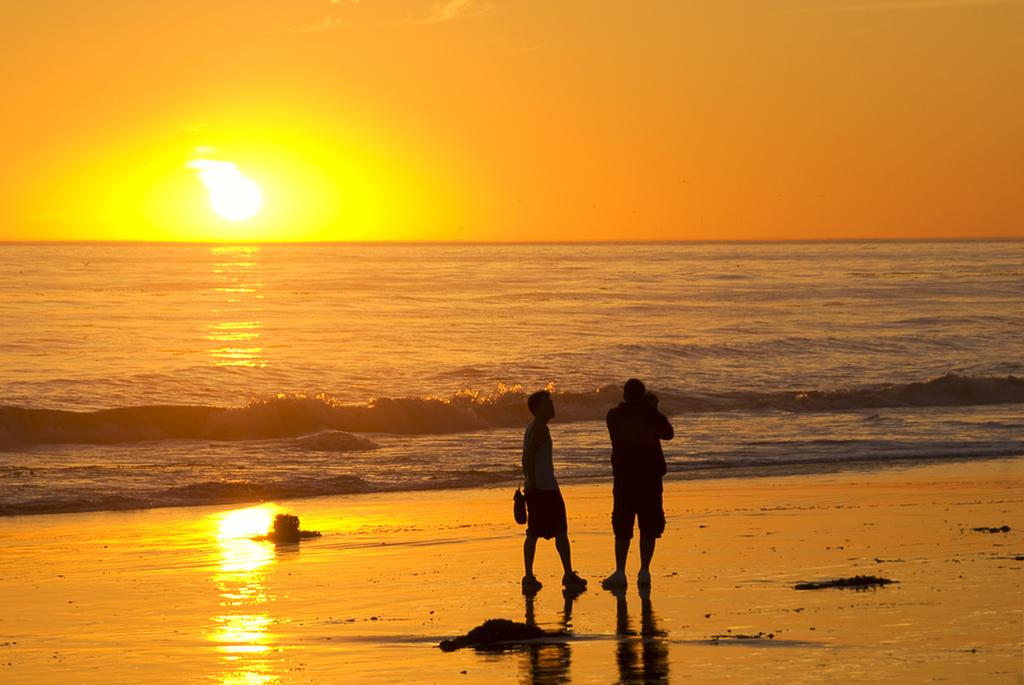How many people are in the image? There are two people in the image. What are the people doing in the image? The people are standing in front of the water. What are the people wearing in the image? The people are wearing dresses. What are the people carrying in the image? The people are carrying bags. What can be seen in the background of the image? The sun and the sky are visible in the back. What type of hate can be seen in the image? There is no hate present in the image; it features two people standing in front of the water. Can you tell me how the people are swimming in the image? The people are not swimming in the image; they are standing in front of the water. 